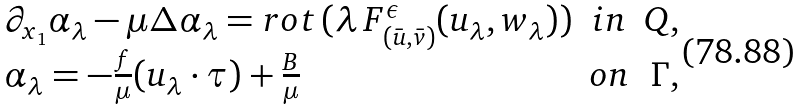<formula> <loc_0><loc_0><loc_500><loc_500>\begin{array} { l c r } \partial _ { x _ { 1 } } \alpha _ { \lambda } - \mu \Delta \alpha _ { \lambda } = r o t \, ( \lambda \, F ^ { \epsilon } _ { ( \bar { u } , \bar { v } ) } ( u _ { \lambda } , w _ { \lambda } ) ) & i n & Q , \\ \alpha _ { \lambda } = - \frac { f } { \mu } ( u _ { \lambda } \cdot \tau ) + \frac { B } { \mu } & o n & \Gamma , \end{array}</formula> 